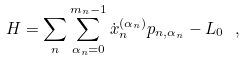<formula> <loc_0><loc_0><loc_500><loc_500>H = \sum _ { n } \sum _ { \alpha _ { n } = 0 } ^ { m _ { n } - 1 } \dot { x } _ { n } ^ { ( \alpha _ { n } ) } p _ { n , \alpha _ { n } } - L _ { 0 } \ ,</formula> 